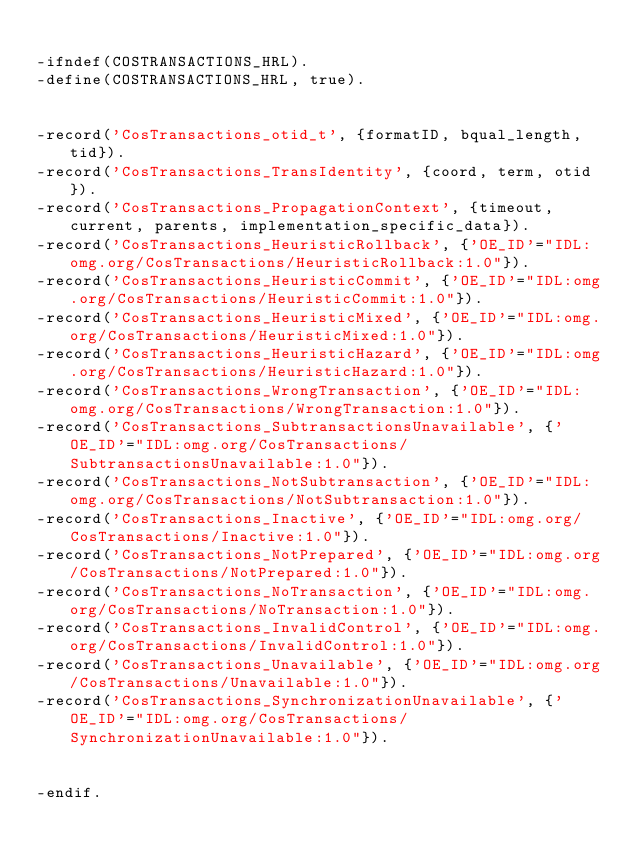<code> <loc_0><loc_0><loc_500><loc_500><_Erlang_>
-ifndef(COSTRANSACTIONS_HRL).
-define(COSTRANSACTIONS_HRL, true).


-record('CosTransactions_otid_t', {formatID, bqual_length, tid}).
-record('CosTransactions_TransIdentity', {coord, term, otid}).
-record('CosTransactions_PropagationContext', {timeout, current, parents, implementation_specific_data}).
-record('CosTransactions_HeuristicRollback', {'OE_ID'="IDL:omg.org/CosTransactions/HeuristicRollback:1.0"}).
-record('CosTransactions_HeuristicCommit', {'OE_ID'="IDL:omg.org/CosTransactions/HeuristicCommit:1.0"}).
-record('CosTransactions_HeuristicMixed', {'OE_ID'="IDL:omg.org/CosTransactions/HeuristicMixed:1.0"}).
-record('CosTransactions_HeuristicHazard', {'OE_ID'="IDL:omg.org/CosTransactions/HeuristicHazard:1.0"}).
-record('CosTransactions_WrongTransaction', {'OE_ID'="IDL:omg.org/CosTransactions/WrongTransaction:1.0"}).
-record('CosTransactions_SubtransactionsUnavailable', {'OE_ID'="IDL:omg.org/CosTransactions/SubtransactionsUnavailable:1.0"}).
-record('CosTransactions_NotSubtransaction', {'OE_ID'="IDL:omg.org/CosTransactions/NotSubtransaction:1.0"}).
-record('CosTransactions_Inactive', {'OE_ID'="IDL:omg.org/CosTransactions/Inactive:1.0"}).
-record('CosTransactions_NotPrepared', {'OE_ID'="IDL:omg.org/CosTransactions/NotPrepared:1.0"}).
-record('CosTransactions_NoTransaction', {'OE_ID'="IDL:omg.org/CosTransactions/NoTransaction:1.0"}).
-record('CosTransactions_InvalidControl', {'OE_ID'="IDL:omg.org/CosTransactions/InvalidControl:1.0"}).
-record('CosTransactions_Unavailable', {'OE_ID'="IDL:omg.org/CosTransactions/Unavailable:1.0"}).
-record('CosTransactions_SynchronizationUnavailable', {'OE_ID'="IDL:omg.org/CosTransactions/SynchronizationUnavailable:1.0"}).


-endif.


</code> 